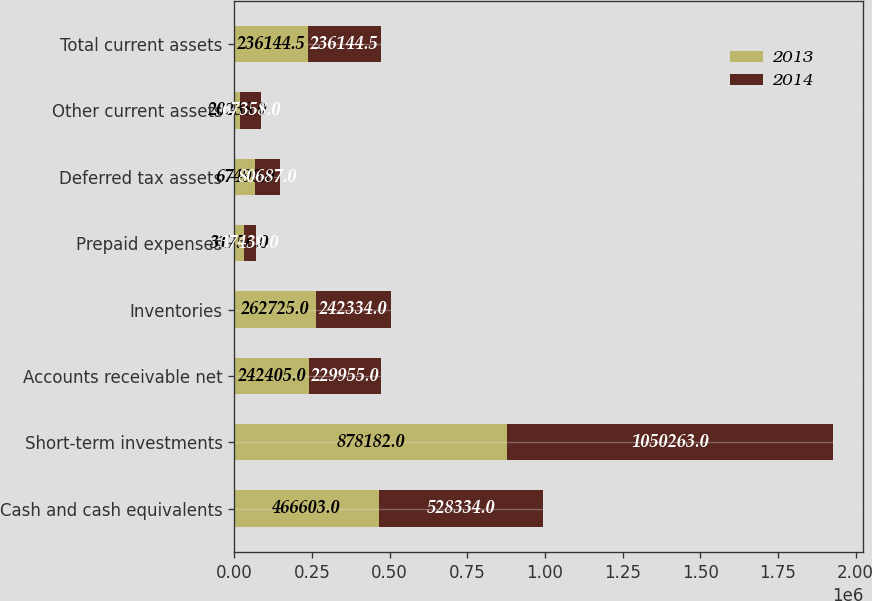Convert chart to OTSL. <chart><loc_0><loc_0><loc_500><loc_500><stacked_bar_chart><ecel><fcel>Cash and cash equivalents<fcel>Short-term investments<fcel>Accounts receivable net<fcel>Inventories<fcel>Prepaid expenses<fcel>Deferred tax assets<fcel>Other current assets<fcel>Total current assets<nl><fcel>2013<fcel>466603<fcel>878182<fcel>242405<fcel>262725<fcel>31756<fcel>67490<fcel>20238<fcel>236144<nl><fcel>2014<fcel>528334<fcel>1.05026e+06<fcel>229955<fcel>242334<fcel>37439<fcel>80687<fcel>67358<fcel>236144<nl></chart> 